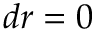Convert formula to latex. <formula><loc_0><loc_0><loc_500><loc_500>d r = 0</formula> 